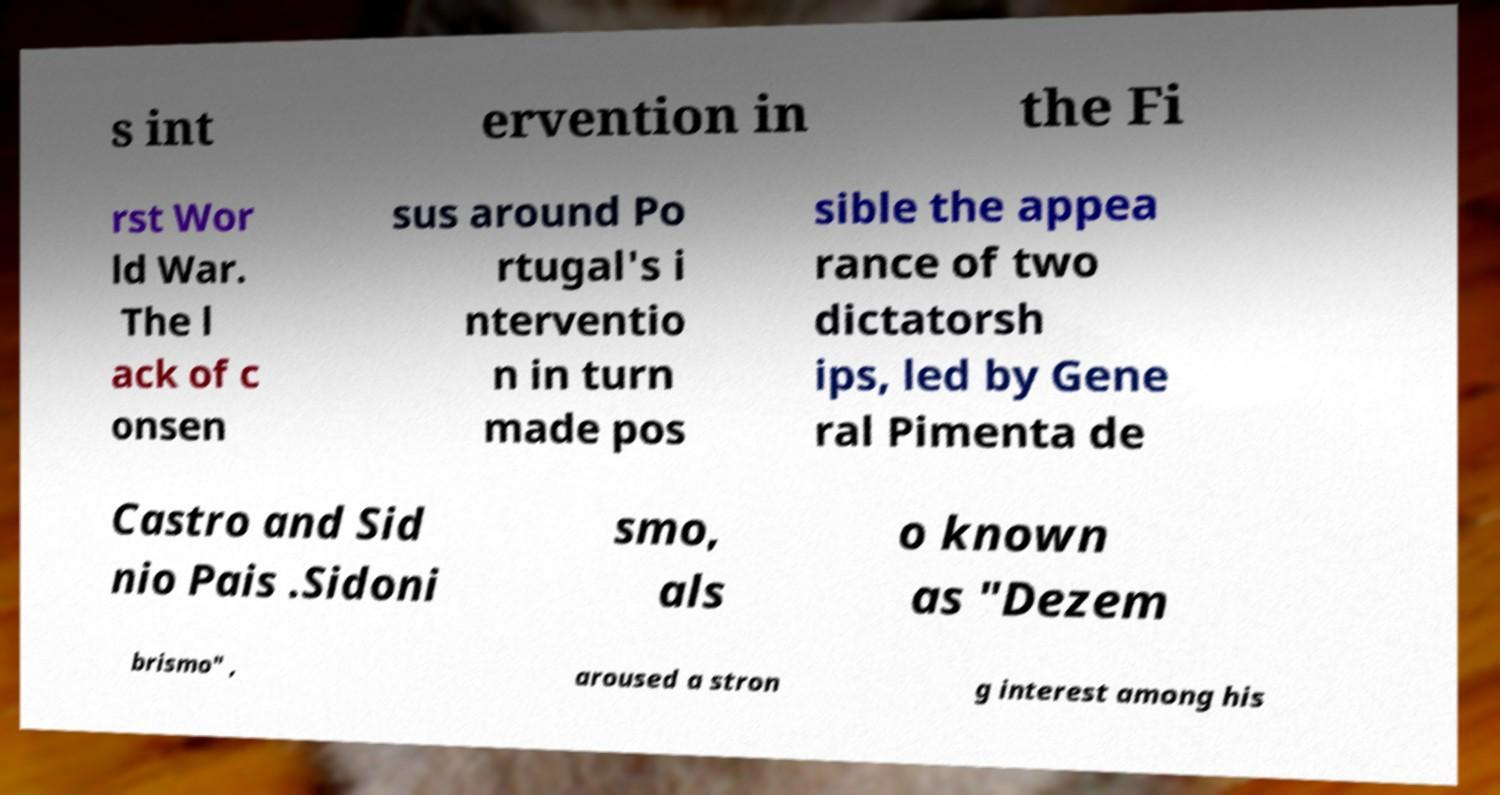Can you accurately transcribe the text from the provided image for me? s int ervention in the Fi rst Wor ld War. The l ack of c onsen sus around Po rtugal's i nterventio n in turn made pos sible the appea rance of two dictatorsh ips, led by Gene ral Pimenta de Castro and Sid nio Pais .Sidoni smo, als o known as "Dezem brismo" , aroused a stron g interest among his 